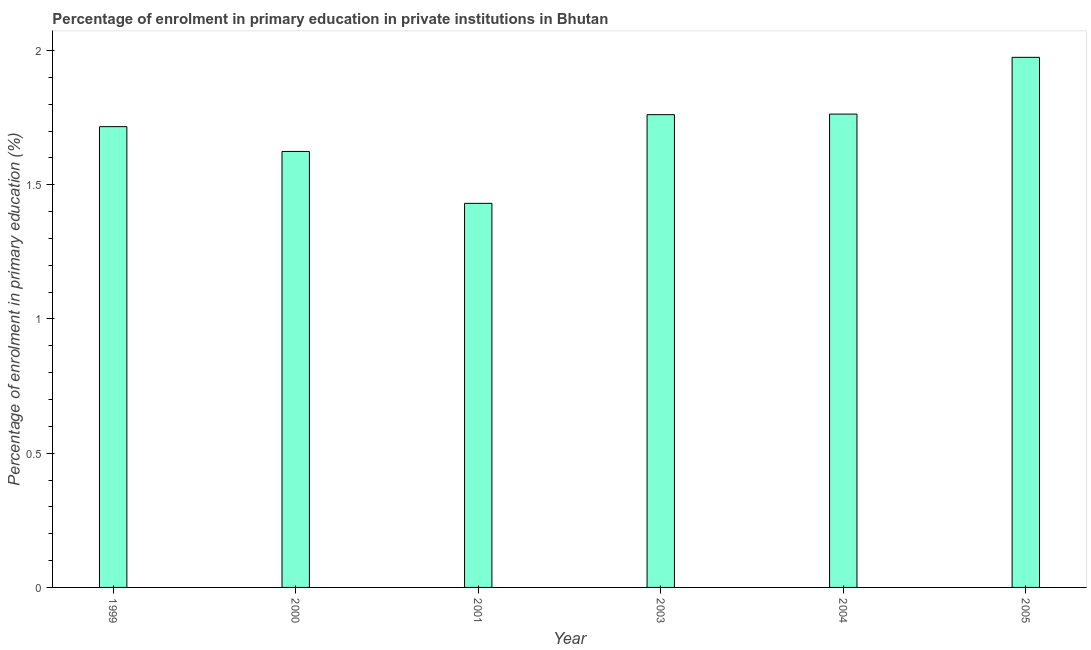Does the graph contain grids?
Offer a very short reply. No. What is the title of the graph?
Provide a short and direct response. Percentage of enrolment in primary education in private institutions in Bhutan. What is the label or title of the Y-axis?
Your response must be concise. Percentage of enrolment in primary education (%). What is the enrolment percentage in primary education in 2004?
Your answer should be compact. 1.76. Across all years, what is the maximum enrolment percentage in primary education?
Keep it short and to the point. 1.97. Across all years, what is the minimum enrolment percentage in primary education?
Provide a short and direct response. 1.43. What is the sum of the enrolment percentage in primary education?
Your answer should be very brief. 10.27. What is the difference between the enrolment percentage in primary education in 1999 and 2003?
Your answer should be compact. -0.04. What is the average enrolment percentage in primary education per year?
Provide a succinct answer. 1.71. What is the median enrolment percentage in primary education?
Your response must be concise. 1.74. What is the ratio of the enrolment percentage in primary education in 1999 to that in 2004?
Offer a very short reply. 0.97. Is the enrolment percentage in primary education in 1999 less than that in 2004?
Offer a very short reply. Yes. What is the difference between the highest and the second highest enrolment percentage in primary education?
Make the answer very short. 0.21. Is the sum of the enrolment percentage in primary education in 2000 and 2004 greater than the maximum enrolment percentage in primary education across all years?
Offer a very short reply. Yes. What is the difference between the highest and the lowest enrolment percentage in primary education?
Your response must be concise. 0.54. In how many years, is the enrolment percentage in primary education greater than the average enrolment percentage in primary education taken over all years?
Offer a terse response. 4. How many bars are there?
Your answer should be very brief. 6. Are all the bars in the graph horizontal?
Offer a terse response. No. Are the values on the major ticks of Y-axis written in scientific E-notation?
Your answer should be very brief. No. What is the Percentage of enrolment in primary education (%) of 1999?
Offer a terse response. 1.72. What is the Percentage of enrolment in primary education (%) in 2000?
Ensure brevity in your answer.  1.62. What is the Percentage of enrolment in primary education (%) in 2001?
Your response must be concise. 1.43. What is the Percentage of enrolment in primary education (%) of 2003?
Make the answer very short. 1.76. What is the Percentage of enrolment in primary education (%) of 2004?
Provide a short and direct response. 1.76. What is the Percentage of enrolment in primary education (%) in 2005?
Give a very brief answer. 1.97. What is the difference between the Percentage of enrolment in primary education (%) in 1999 and 2000?
Your response must be concise. 0.09. What is the difference between the Percentage of enrolment in primary education (%) in 1999 and 2001?
Your answer should be compact. 0.29. What is the difference between the Percentage of enrolment in primary education (%) in 1999 and 2003?
Offer a terse response. -0.04. What is the difference between the Percentage of enrolment in primary education (%) in 1999 and 2004?
Give a very brief answer. -0.05. What is the difference between the Percentage of enrolment in primary education (%) in 1999 and 2005?
Give a very brief answer. -0.26. What is the difference between the Percentage of enrolment in primary education (%) in 2000 and 2001?
Provide a succinct answer. 0.19. What is the difference between the Percentage of enrolment in primary education (%) in 2000 and 2003?
Ensure brevity in your answer.  -0.14. What is the difference between the Percentage of enrolment in primary education (%) in 2000 and 2004?
Keep it short and to the point. -0.14. What is the difference between the Percentage of enrolment in primary education (%) in 2000 and 2005?
Offer a terse response. -0.35. What is the difference between the Percentage of enrolment in primary education (%) in 2001 and 2003?
Your response must be concise. -0.33. What is the difference between the Percentage of enrolment in primary education (%) in 2001 and 2004?
Your response must be concise. -0.33. What is the difference between the Percentage of enrolment in primary education (%) in 2001 and 2005?
Provide a succinct answer. -0.54. What is the difference between the Percentage of enrolment in primary education (%) in 2003 and 2004?
Ensure brevity in your answer.  -0. What is the difference between the Percentage of enrolment in primary education (%) in 2003 and 2005?
Provide a short and direct response. -0.21. What is the difference between the Percentage of enrolment in primary education (%) in 2004 and 2005?
Your answer should be very brief. -0.21. What is the ratio of the Percentage of enrolment in primary education (%) in 1999 to that in 2000?
Your response must be concise. 1.06. What is the ratio of the Percentage of enrolment in primary education (%) in 1999 to that in 2001?
Your answer should be very brief. 1.2. What is the ratio of the Percentage of enrolment in primary education (%) in 1999 to that in 2005?
Offer a terse response. 0.87. What is the ratio of the Percentage of enrolment in primary education (%) in 2000 to that in 2001?
Provide a short and direct response. 1.14. What is the ratio of the Percentage of enrolment in primary education (%) in 2000 to that in 2003?
Your response must be concise. 0.92. What is the ratio of the Percentage of enrolment in primary education (%) in 2000 to that in 2004?
Provide a succinct answer. 0.92. What is the ratio of the Percentage of enrolment in primary education (%) in 2000 to that in 2005?
Provide a succinct answer. 0.82. What is the ratio of the Percentage of enrolment in primary education (%) in 2001 to that in 2003?
Your answer should be compact. 0.81. What is the ratio of the Percentage of enrolment in primary education (%) in 2001 to that in 2004?
Make the answer very short. 0.81. What is the ratio of the Percentage of enrolment in primary education (%) in 2001 to that in 2005?
Your answer should be very brief. 0.72. What is the ratio of the Percentage of enrolment in primary education (%) in 2003 to that in 2005?
Ensure brevity in your answer.  0.89. What is the ratio of the Percentage of enrolment in primary education (%) in 2004 to that in 2005?
Keep it short and to the point. 0.89. 